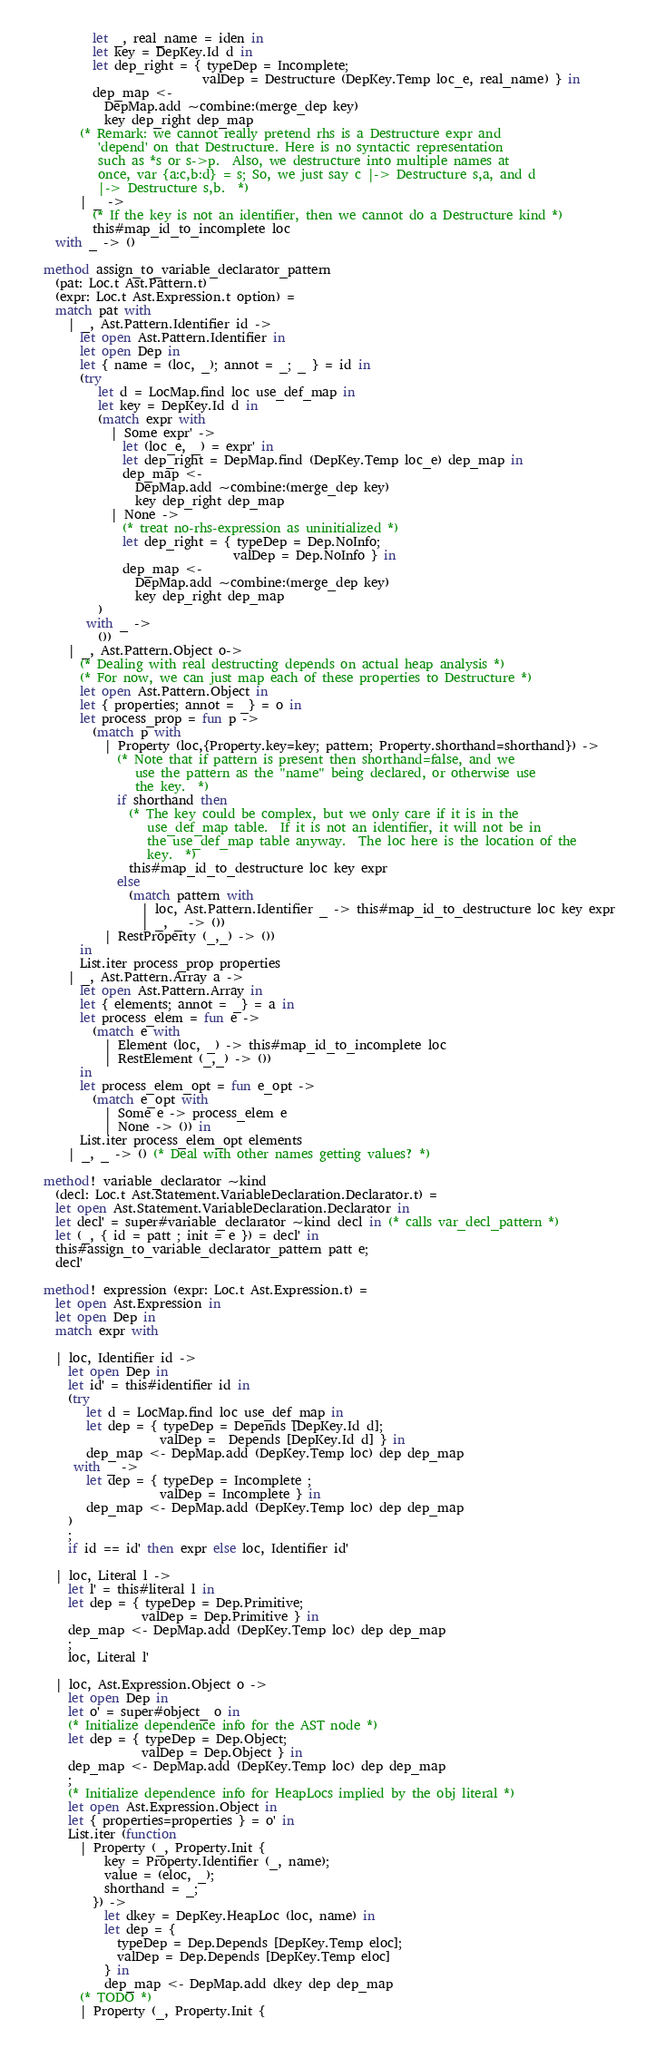<code> <loc_0><loc_0><loc_500><loc_500><_OCaml_>          let _, real_name = iden in
          let key = DepKey.Id d in
          let dep_right = { typeDep = Incomplete;
                            valDep = Destructure (DepKey.Temp loc_e, real_name) } in
          dep_map <-
            DepMap.add ~combine:(merge_dep key)
            key dep_right dep_map
        (* Remark: we cannot really pretend rhs is a Destructure expr and
           'depend' on that Destructure. Here is no syntactic representation
           such as *s or s->p.  Also, we destructure into multiple names at
           once, var {a:c,b:d} = s; So, we just say c |-> Destructure s,a, and d
           |-> Destructure s,b.  *)
        | _ ->
          (* If the key is not an identifier, then we cannot do a Destructure kind *)
          this#map_id_to_incomplete loc
    with _ -> ()

  method assign_to_variable_declarator_pattern
    (pat: Loc.t Ast.Pattern.t)
    (expr: Loc.t Ast.Expression.t option) =
    match pat with
      | _, Ast.Pattern.Identifier id ->
        let open Ast.Pattern.Identifier in
        let open Dep in
        let { name = (loc, _); annot = _; _ } = id in
        (try
           let d = LocMap.find loc use_def_map in
           let key = DepKey.Id d in
           (match expr with
             | Some expr' ->
               let (loc_e, _) = expr' in
               let dep_right = DepMap.find (DepKey.Temp loc_e) dep_map in
               dep_map <-
                 DepMap.add ~combine:(merge_dep key)
                 key dep_right dep_map
             | None ->
               (* treat no-rhs-expression as uninitialized *)
               let dep_right = { typeDep = Dep.NoInfo;
                                 valDep = Dep.NoInfo } in
               dep_map <-
                 DepMap.add ~combine:(merge_dep key)
                 key dep_right dep_map
           )
         with _ ->
           ())
      | _, Ast.Pattern.Object o->
        (* Dealing with real destructing depends on actual heap analysis *)
        (* For now, we can just map each of these properties to Destructure *)
        let open Ast.Pattern.Object in
        let { properties; annot = _} = o in
        let process_prop = fun p ->
          (match p with
            | Property (loc,{Property.key=key; pattern; Property.shorthand=shorthand}) ->
              (* Note that if pattern is present then shorthand=false, and we
                 use the pattern as the "name" being declared, or otherwise use
                 the key.  *)
              if shorthand then
                (* The key could be complex, but we only care if it is in the
                   use_def_map table.  If it is not an identifier, it will not be in
                   the use_def_map table anyway.  The loc here is the location of the
                   key.  *)
                this#map_id_to_destructure loc key expr
              else
                (match pattern with
                  | loc, Ast.Pattern.Identifier _ -> this#map_id_to_destructure loc key expr
                  | _, _ -> ())
            | RestProperty (_,_) -> ())
        in
        List.iter process_prop properties
      | _, Ast.Pattern.Array a ->
        let open Ast.Pattern.Array in
        let { elements; annot = _} = a in
        let process_elem = fun e ->
          (match e with
            | Element (loc, _) -> this#map_id_to_incomplete loc
            | RestElement (_,_) -> ())
        in
        let process_elem_opt = fun e_opt ->
          (match e_opt with
            | Some e -> process_elem e
            | None -> ()) in
        List.iter process_elem_opt elements
      | _, _ -> () (* Deal with other names getting values? *)

  method! variable_declarator ~kind
    (decl: Loc.t Ast.Statement.VariableDeclaration.Declarator.t) =
    let open Ast.Statement.VariableDeclaration.Declarator in
    let decl' = super#variable_declarator ~kind decl in (* calls var_decl_pattern *)
    let (_, { id = patt ; init = e }) = decl' in
    this#assign_to_variable_declarator_pattern patt e;
    decl'

  method! expression (expr: Loc.t Ast.Expression.t) =
    let open Ast.Expression in
    let open Dep in
    match expr with

    | loc, Identifier id ->
      let open Dep in
      let id' = this#identifier id in
      (try
         let d = LocMap.find loc use_def_map in
         let dep = { typeDep = Depends [DepKey.Id d];
                     valDep =  Depends [DepKey.Id d] } in
         dep_map <- DepMap.add (DepKey.Temp loc) dep dep_map
       with _ ->
         let dep = { typeDep = Incomplete ;
                     valDep = Incomplete } in
         dep_map <- DepMap.add (DepKey.Temp loc) dep dep_map
      )
      ;
      if id == id' then expr else loc, Identifier id'

    | loc, Literal l ->
      let l' = this#literal l in
      let dep = { typeDep = Dep.Primitive;
                  valDep = Dep.Primitive } in
      dep_map <- DepMap.add (DepKey.Temp loc) dep dep_map
      ;
      loc, Literal l'

    | loc, Ast.Expression.Object o ->
      let open Dep in
      let o' = super#object_ o in
      (* Initialize dependence info for the AST node *)
      let dep = { typeDep = Dep.Object;
                  valDep = Dep.Object } in
      dep_map <- DepMap.add (DepKey.Temp loc) dep dep_map
      ;
      (* Initialize dependence info for HeapLocs implied by the obj literal *)
      let open Ast.Expression.Object in
      let { properties=properties } = o' in
      List.iter (function
        | Property (_, Property.Init {
            key = Property.Identifier (_, name);
            value = (eloc, _);
            shorthand = _;
          }) ->
            let dkey = DepKey.HeapLoc (loc, name) in
            let dep = {
              typeDep = Dep.Depends [DepKey.Temp eloc];
              valDep = Dep.Depends [DepKey.Temp eloc]
            } in
            dep_map <- DepMap.add dkey dep dep_map
        (* TODO *)
        | Property (_, Property.Init {</code> 